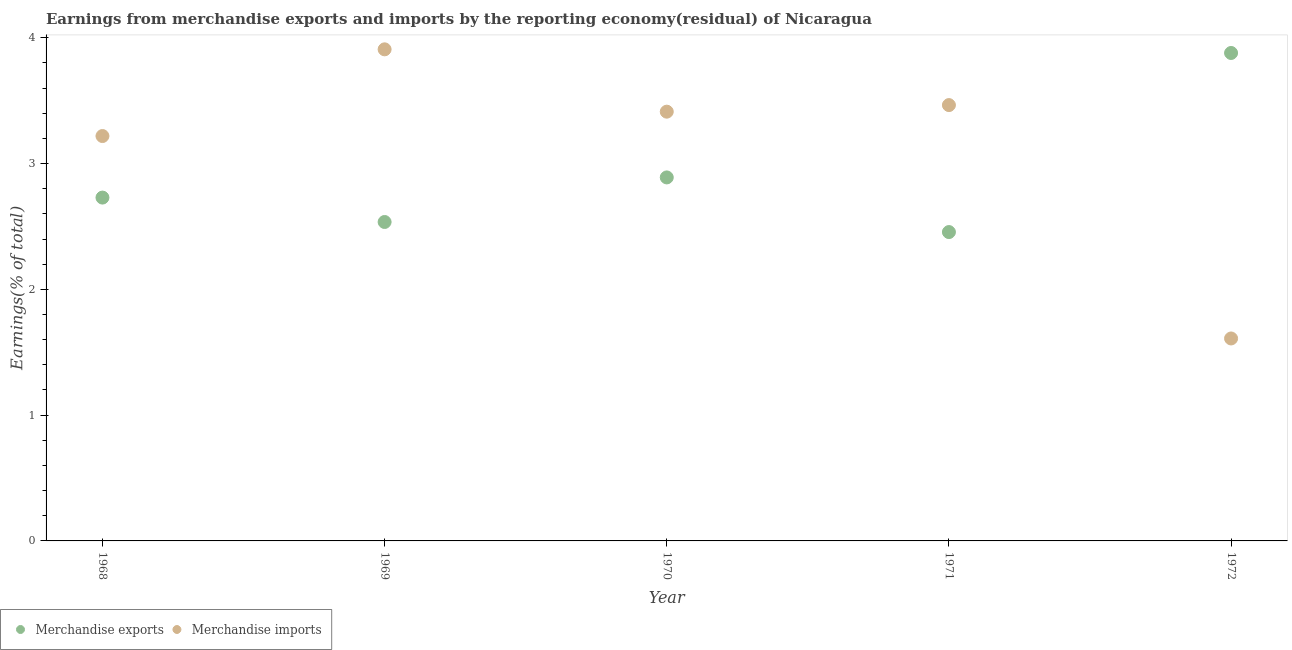How many different coloured dotlines are there?
Offer a terse response. 2. What is the earnings from merchandise imports in 1970?
Give a very brief answer. 3.41. Across all years, what is the maximum earnings from merchandise imports?
Offer a terse response. 3.91. Across all years, what is the minimum earnings from merchandise imports?
Your answer should be very brief. 1.61. In which year was the earnings from merchandise exports maximum?
Ensure brevity in your answer.  1972. In which year was the earnings from merchandise exports minimum?
Ensure brevity in your answer.  1971. What is the total earnings from merchandise imports in the graph?
Ensure brevity in your answer.  15.61. What is the difference between the earnings from merchandise exports in 1968 and that in 1972?
Give a very brief answer. -1.15. What is the difference between the earnings from merchandise exports in 1968 and the earnings from merchandise imports in 1971?
Make the answer very short. -0.74. What is the average earnings from merchandise imports per year?
Provide a short and direct response. 3.12. In the year 1971, what is the difference between the earnings from merchandise exports and earnings from merchandise imports?
Offer a terse response. -1.01. In how many years, is the earnings from merchandise imports greater than 2.6 %?
Offer a very short reply. 4. What is the ratio of the earnings from merchandise imports in 1968 to that in 1970?
Your answer should be compact. 0.94. Is the earnings from merchandise imports in 1969 less than that in 1971?
Your answer should be compact. No. What is the difference between the highest and the second highest earnings from merchandise imports?
Make the answer very short. 0.44. What is the difference between the highest and the lowest earnings from merchandise imports?
Give a very brief answer. 2.3. In how many years, is the earnings from merchandise imports greater than the average earnings from merchandise imports taken over all years?
Your answer should be compact. 4. Is the sum of the earnings from merchandise exports in 1969 and 1970 greater than the maximum earnings from merchandise imports across all years?
Offer a very short reply. Yes. Does the earnings from merchandise exports monotonically increase over the years?
Offer a terse response. No. Is the earnings from merchandise exports strictly greater than the earnings from merchandise imports over the years?
Make the answer very short. No. Does the graph contain any zero values?
Offer a terse response. No. Does the graph contain grids?
Offer a very short reply. No. How many legend labels are there?
Offer a terse response. 2. What is the title of the graph?
Give a very brief answer. Earnings from merchandise exports and imports by the reporting economy(residual) of Nicaragua. What is the label or title of the X-axis?
Make the answer very short. Year. What is the label or title of the Y-axis?
Provide a short and direct response. Earnings(% of total). What is the Earnings(% of total) of Merchandise exports in 1968?
Offer a terse response. 2.73. What is the Earnings(% of total) of Merchandise imports in 1968?
Ensure brevity in your answer.  3.22. What is the Earnings(% of total) of Merchandise exports in 1969?
Your response must be concise. 2.54. What is the Earnings(% of total) of Merchandise imports in 1969?
Keep it short and to the point. 3.91. What is the Earnings(% of total) in Merchandise exports in 1970?
Offer a terse response. 2.89. What is the Earnings(% of total) in Merchandise imports in 1970?
Give a very brief answer. 3.41. What is the Earnings(% of total) in Merchandise exports in 1971?
Your answer should be very brief. 2.46. What is the Earnings(% of total) in Merchandise imports in 1971?
Give a very brief answer. 3.46. What is the Earnings(% of total) of Merchandise exports in 1972?
Make the answer very short. 3.88. What is the Earnings(% of total) of Merchandise imports in 1972?
Offer a terse response. 1.61. Across all years, what is the maximum Earnings(% of total) of Merchandise exports?
Your answer should be very brief. 3.88. Across all years, what is the maximum Earnings(% of total) of Merchandise imports?
Ensure brevity in your answer.  3.91. Across all years, what is the minimum Earnings(% of total) of Merchandise exports?
Your answer should be very brief. 2.46. Across all years, what is the minimum Earnings(% of total) in Merchandise imports?
Ensure brevity in your answer.  1.61. What is the total Earnings(% of total) of Merchandise exports in the graph?
Offer a terse response. 14.49. What is the total Earnings(% of total) in Merchandise imports in the graph?
Make the answer very short. 15.61. What is the difference between the Earnings(% of total) of Merchandise exports in 1968 and that in 1969?
Offer a terse response. 0.19. What is the difference between the Earnings(% of total) in Merchandise imports in 1968 and that in 1969?
Ensure brevity in your answer.  -0.69. What is the difference between the Earnings(% of total) in Merchandise exports in 1968 and that in 1970?
Your answer should be very brief. -0.16. What is the difference between the Earnings(% of total) of Merchandise imports in 1968 and that in 1970?
Your answer should be compact. -0.19. What is the difference between the Earnings(% of total) of Merchandise exports in 1968 and that in 1971?
Your answer should be very brief. 0.27. What is the difference between the Earnings(% of total) in Merchandise imports in 1968 and that in 1971?
Make the answer very short. -0.25. What is the difference between the Earnings(% of total) in Merchandise exports in 1968 and that in 1972?
Keep it short and to the point. -1.15. What is the difference between the Earnings(% of total) in Merchandise imports in 1968 and that in 1972?
Your response must be concise. 1.61. What is the difference between the Earnings(% of total) in Merchandise exports in 1969 and that in 1970?
Provide a succinct answer. -0.35. What is the difference between the Earnings(% of total) in Merchandise imports in 1969 and that in 1970?
Your answer should be very brief. 0.5. What is the difference between the Earnings(% of total) in Merchandise exports in 1969 and that in 1971?
Provide a succinct answer. 0.08. What is the difference between the Earnings(% of total) in Merchandise imports in 1969 and that in 1971?
Keep it short and to the point. 0.44. What is the difference between the Earnings(% of total) in Merchandise exports in 1969 and that in 1972?
Ensure brevity in your answer.  -1.34. What is the difference between the Earnings(% of total) of Merchandise imports in 1969 and that in 1972?
Offer a very short reply. 2.3. What is the difference between the Earnings(% of total) of Merchandise exports in 1970 and that in 1971?
Your answer should be compact. 0.43. What is the difference between the Earnings(% of total) of Merchandise imports in 1970 and that in 1971?
Offer a very short reply. -0.05. What is the difference between the Earnings(% of total) in Merchandise exports in 1970 and that in 1972?
Your answer should be very brief. -0.99. What is the difference between the Earnings(% of total) of Merchandise imports in 1970 and that in 1972?
Your response must be concise. 1.8. What is the difference between the Earnings(% of total) in Merchandise exports in 1971 and that in 1972?
Your response must be concise. -1.42. What is the difference between the Earnings(% of total) in Merchandise imports in 1971 and that in 1972?
Your answer should be very brief. 1.86. What is the difference between the Earnings(% of total) in Merchandise exports in 1968 and the Earnings(% of total) in Merchandise imports in 1969?
Your answer should be compact. -1.18. What is the difference between the Earnings(% of total) of Merchandise exports in 1968 and the Earnings(% of total) of Merchandise imports in 1970?
Provide a succinct answer. -0.68. What is the difference between the Earnings(% of total) in Merchandise exports in 1968 and the Earnings(% of total) in Merchandise imports in 1971?
Your answer should be very brief. -0.74. What is the difference between the Earnings(% of total) of Merchandise exports in 1968 and the Earnings(% of total) of Merchandise imports in 1972?
Give a very brief answer. 1.12. What is the difference between the Earnings(% of total) in Merchandise exports in 1969 and the Earnings(% of total) in Merchandise imports in 1970?
Your answer should be compact. -0.88. What is the difference between the Earnings(% of total) of Merchandise exports in 1969 and the Earnings(% of total) of Merchandise imports in 1971?
Your answer should be compact. -0.93. What is the difference between the Earnings(% of total) of Merchandise exports in 1969 and the Earnings(% of total) of Merchandise imports in 1972?
Your response must be concise. 0.93. What is the difference between the Earnings(% of total) in Merchandise exports in 1970 and the Earnings(% of total) in Merchandise imports in 1971?
Provide a succinct answer. -0.58. What is the difference between the Earnings(% of total) in Merchandise exports in 1970 and the Earnings(% of total) in Merchandise imports in 1972?
Give a very brief answer. 1.28. What is the difference between the Earnings(% of total) of Merchandise exports in 1971 and the Earnings(% of total) of Merchandise imports in 1972?
Your answer should be compact. 0.85. What is the average Earnings(% of total) of Merchandise exports per year?
Keep it short and to the point. 2.9. What is the average Earnings(% of total) of Merchandise imports per year?
Keep it short and to the point. 3.12. In the year 1968, what is the difference between the Earnings(% of total) in Merchandise exports and Earnings(% of total) in Merchandise imports?
Offer a very short reply. -0.49. In the year 1969, what is the difference between the Earnings(% of total) of Merchandise exports and Earnings(% of total) of Merchandise imports?
Give a very brief answer. -1.37. In the year 1970, what is the difference between the Earnings(% of total) in Merchandise exports and Earnings(% of total) in Merchandise imports?
Give a very brief answer. -0.52. In the year 1971, what is the difference between the Earnings(% of total) in Merchandise exports and Earnings(% of total) in Merchandise imports?
Keep it short and to the point. -1.01. In the year 1972, what is the difference between the Earnings(% of total) in Merchandise exports and Earnings(% of total) in Merchandise imports?
Provide a short and direct response. 2.27. What is the ratio of the Earnings(% of total) in Merchandise exports in 1968 to that in 1969?
Provide a succinct answer. 1.08. What is the ratio of the Earnings(% of total) of Merchandise imports in 1968 to that in 1969?
Your answer should be very brief. 0.82. What is the ratio of the Earnings(% of total) of Merchandise exports in 1968 to that in 1970?
Offer a very short reply. 0.94. What is the ratio of the Earnings(% of total) in Merchandise imports in 1968 to that in 1970?
Provide a short and direct response. 0.94. What is the ratio of the Earnings(% of total) of Merchandise exports in 1968 to that in 1971?
Your response must be concise. 1.11. What is the ratio of the Earnings(% of total) of Merchandise imports in 1968 to that in 1971?
Your response must be concise. 0.93. What is the ratio of the Earnings(% of total) of Merchandise exports in 1968 to that in 1972?
Make the answer very short. 0.7. What is the ratio of the Earnings(% of total) in Merchandise imports in 1968 to that in 1972?
Offer a terse response. 2. What is the ratio of the Earnings(% of total) of Merchandise exports in 1969 to that in 1970?
Your answer should be compact. 0.88. What is the ratio of the Earnings(% of total) of Merchandise imports in 1969 to that in 1970?
Your response must be concise. 1.15. What is the ratio of the Earnings(% of total) of Merchandise exports in 1969 to that in 1971?
Your answer should be compact. 1.03. What is the ratio of the Earnings(% of total) in Merchandise imports in 1969 to that in 1971?
Make the answer very short. 1.13. What is the ratio of the Earnings(% of total) of Merchandise exports in 1969 to that in 1972?
Your answer should be compact. 0.65. What is the ratio of the Earnings(% of total) of Merchandise imports in 1969 to that in 1972?
Make the answer very short. 2.43. What is the ratio of the Earnings(% of total) in Merchandise exports in 1970 to that in 1971?
Keep it short and to the point. 1.18. What is the ratio of the Earnings(% of total) of Merchandise imports in 1970 to that in 1971?
Give a very brief answer. 0.98. What is the ratio of the Earnings(% of total) of Merchandise exports in 1970 to that in 1972?
Your answer should be compact. 0.74. What is the ratio of the Earnings(% of total) of Merchandise imports in 1970 to that in 1972?
Provide a succinct answer. 2.12. What is the ratio of the Earnings(% of total) in Merchandise exports in 1971 to that in 1972?
Ensure brevity in your answer.  0.63. What is the ratio of the Earnings(% of total) in Merchandise imports in 1971 to that in 1972?
Provide a short and direct response. 2.15. What is the difference between the highest and the second highest Earnings(% of total) of Merchandise exports?
Your answer should be very brief. 0.99. What is the difference between the highest and the second highest Earnings(% of total) in Merchandise imports?
Give a very brief answer. 0.44. What is the difference between the highest and the lowest Earnings(% of total) in Merchandise exports?
Keep it short and to the point. 1.42. What is the difference between the highest and the lowest Earnings(% of total) in Merchandise imports?
Ensure brevity in your answer.  2.3. 